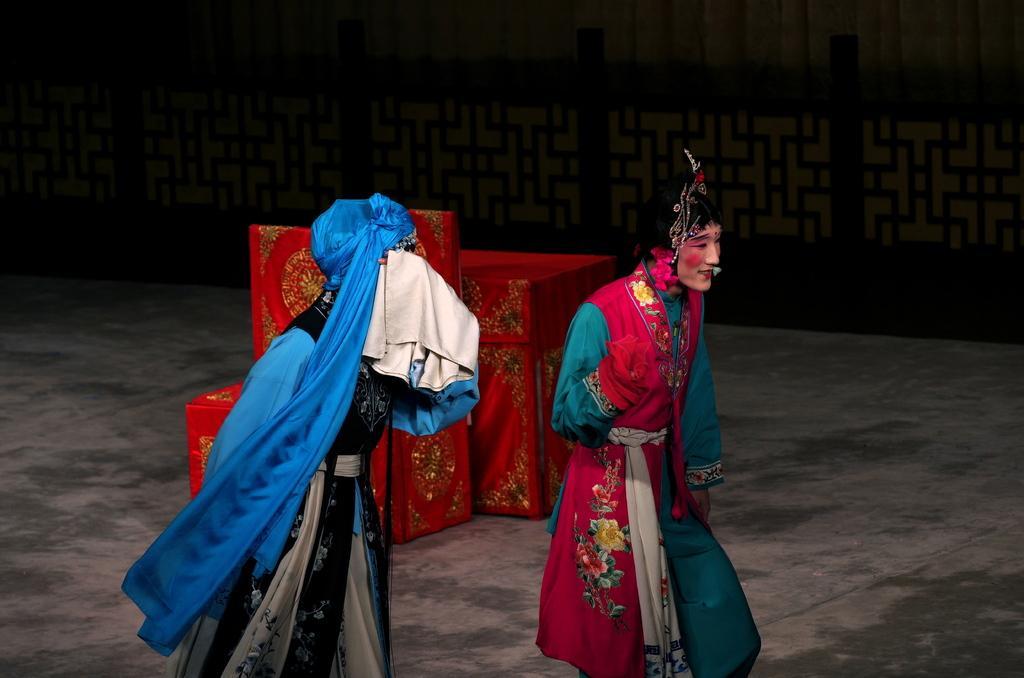Can you describe this image briefly? In this image in the front there are persons. In the background there are objects which are red in colour and there is an object which is black in colour. 